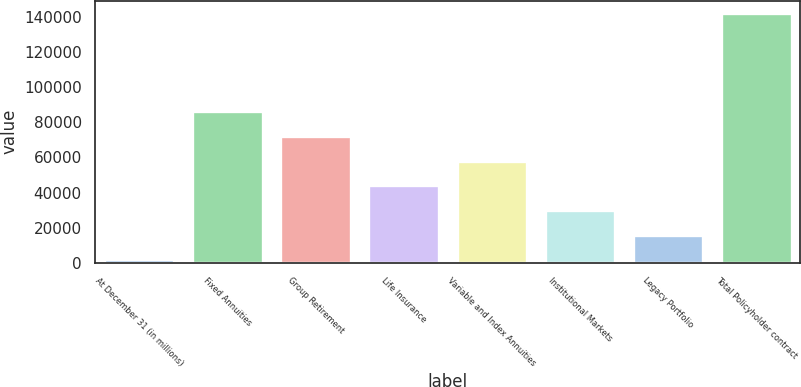Convert chart. <chart><loc_0><loc_0><loc_500><loc_500><bar_chart><fcel>At December 31 (in millions)<fcel>Fixed Annuities<fcel>Group Retirement<fcel>Life Insurance<fcel>Variable and Index Annuities<fcel>Institutional Markets<fcel>Legacy Portfolio<fcel>Total Policyholder contract<nl><fcel>2018<fcel>86164.4<fcel>72140<fcel>44091.2<fcel>58115.6<fcel>30066.8<fcel>16042.4<fcel>142262<nl></chart> 